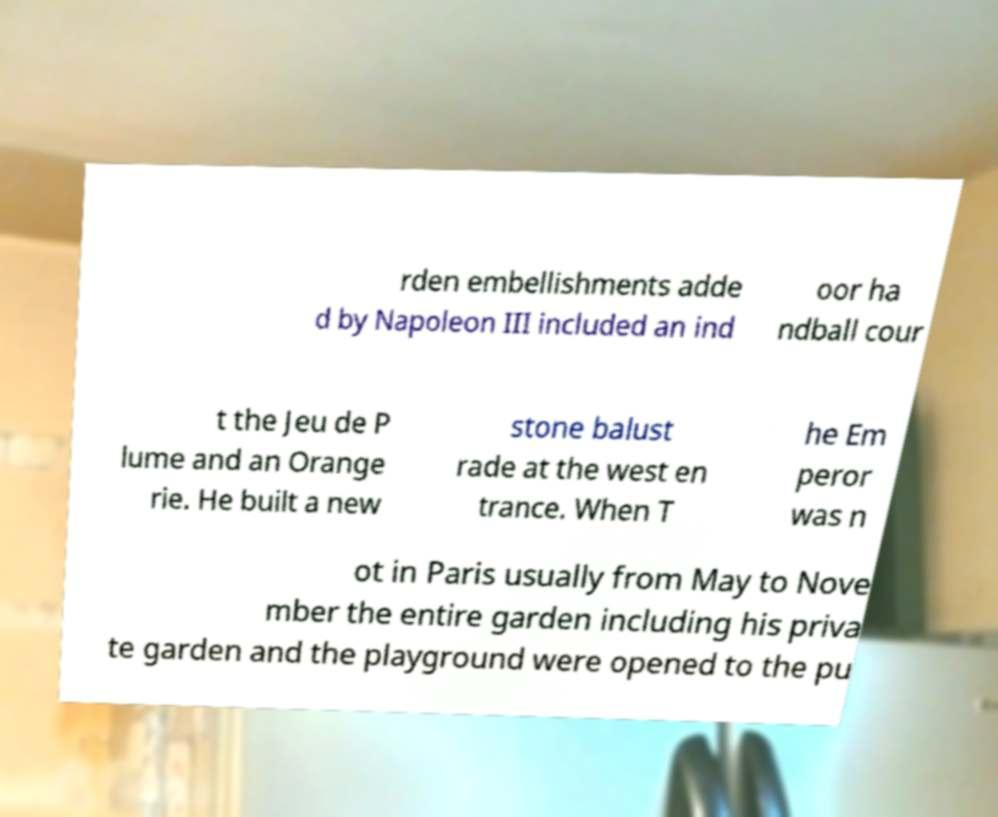There's text embedded in this image that I need extracted. Can you transcribe it verbatim? rden embellishments adde d by Napoleon III included an ind oor ha ndball cour t the Jeu de P lume and an Orange rie. He built a new stone balust rade at the west en trance. When T he Em peror was n ot in Paris usually from May to Nove mber the entire garden including his priva te garden and the playground were opened to the pu 